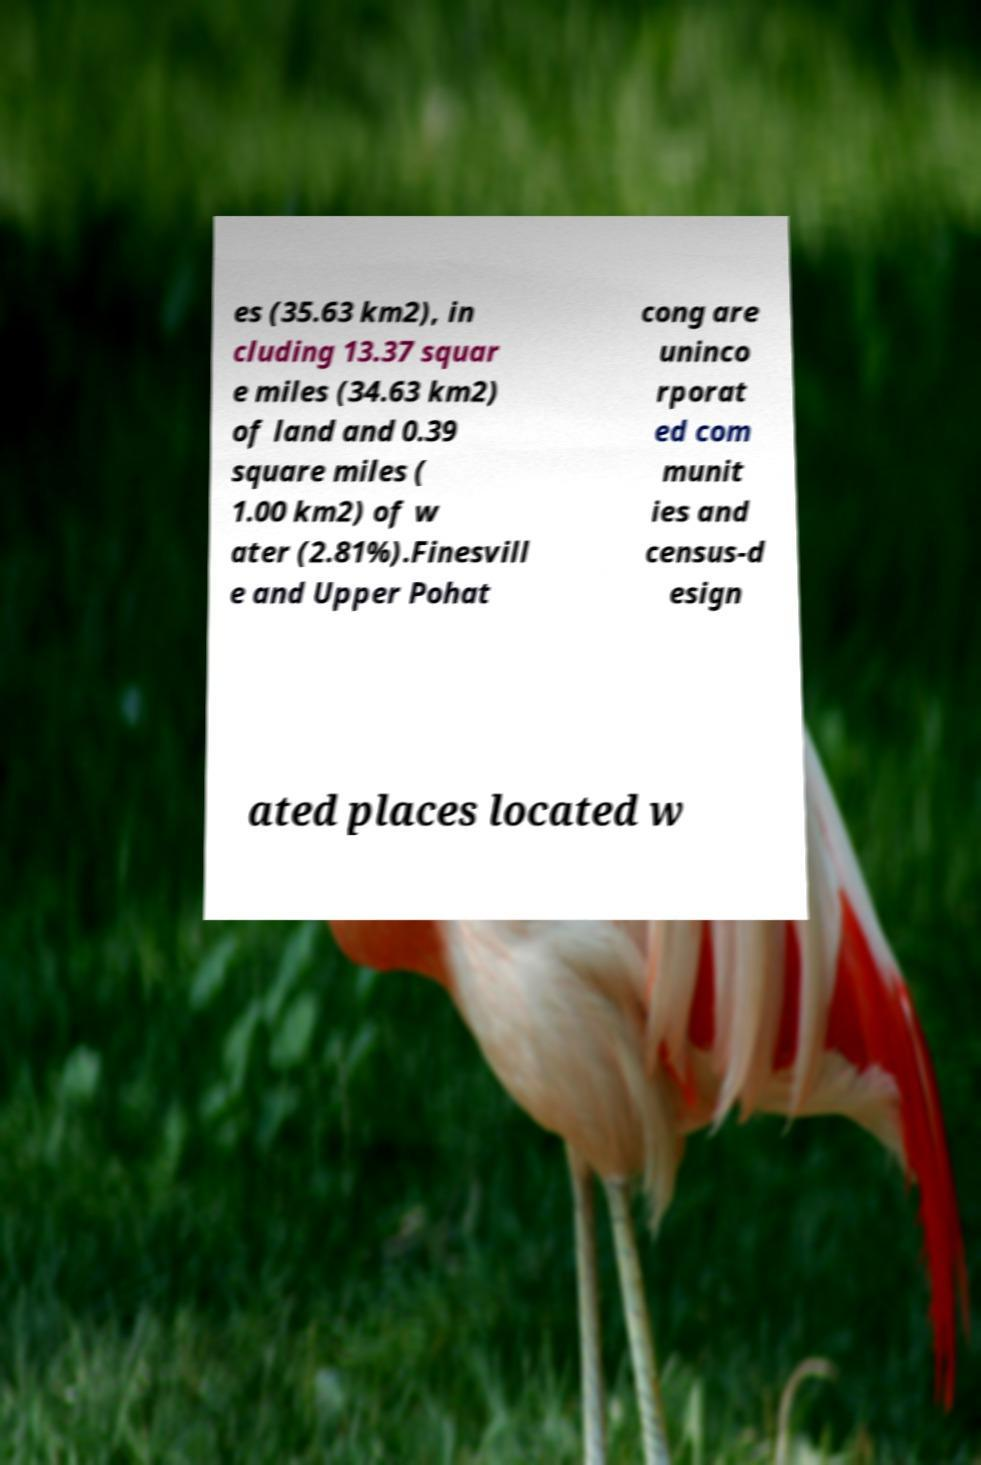What messages or text are displayed in this image? I need them in a readable, typed format. es (35.63 km2), in cluding 13.37 squar e miles (34.63 km2) of land and 0.39 square miles ( 1.00 km2) of w ater (2.81%).Finesvill e and Upper Pohat cong are uninco rporat ed com munit ies and census-d esign ated places located w 